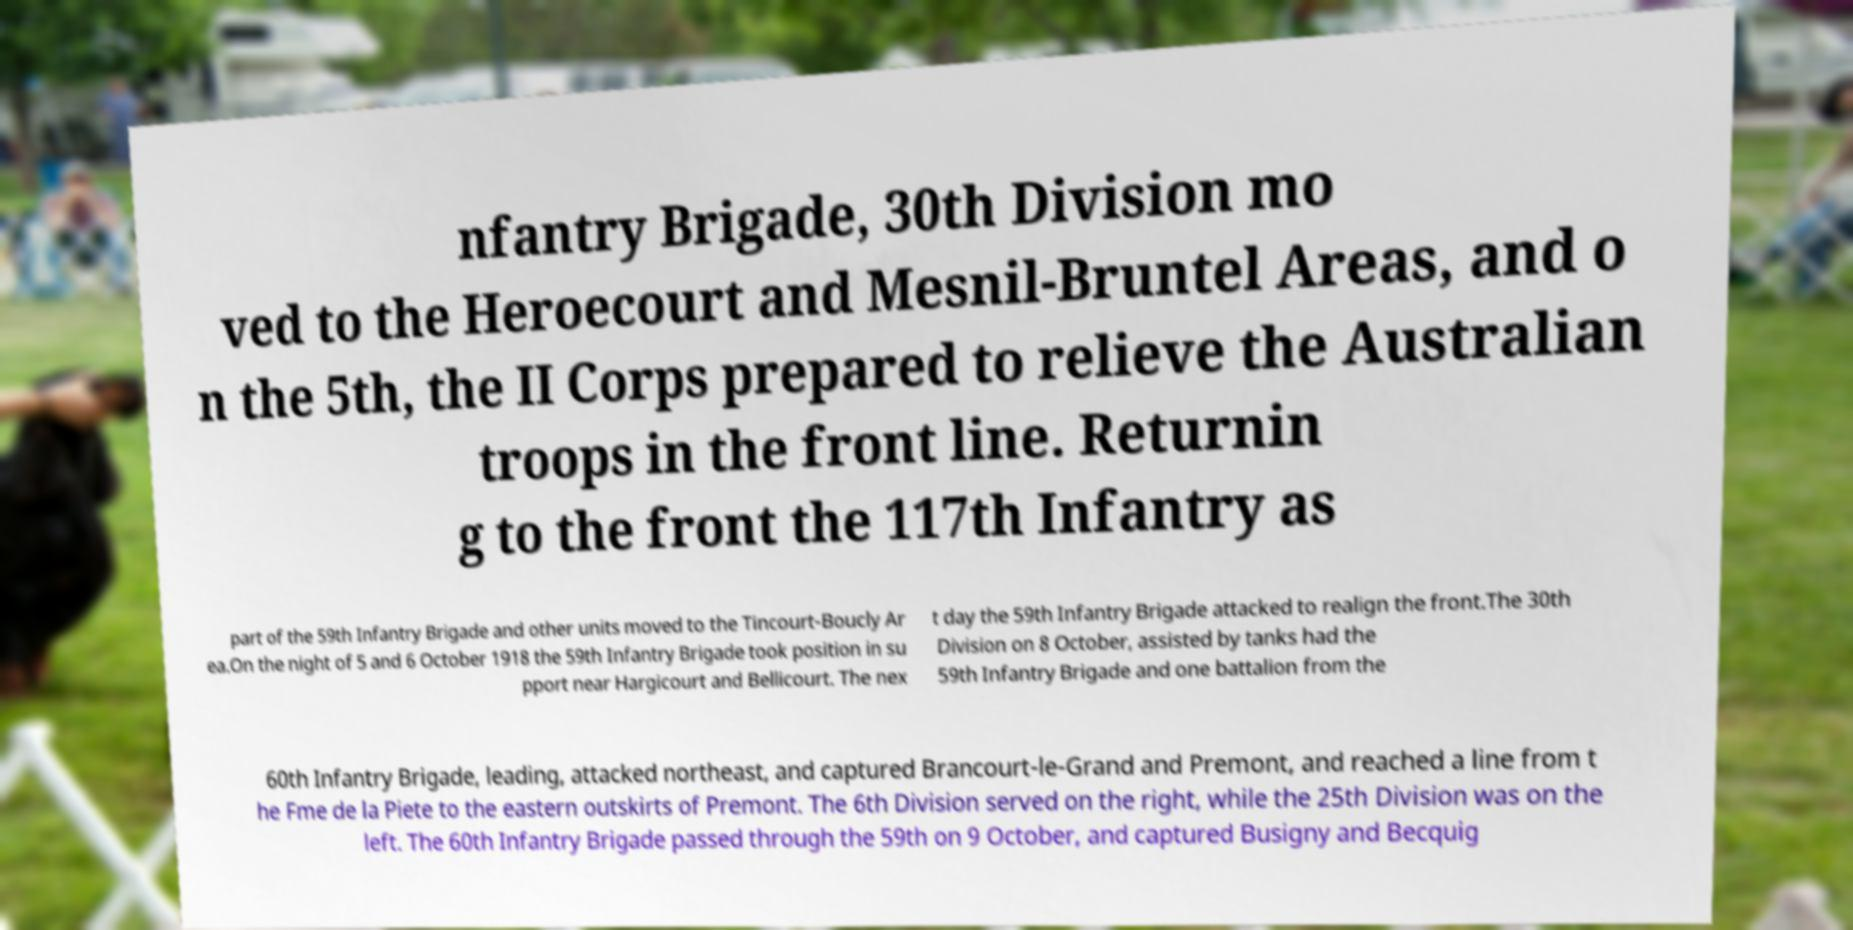Could you assist in decoding the text presented in this image and type it out clearly? nfantry Brigade, 30th Division mo ved to the Heroecourt and Mesnil-Bruntel Areas, and o n the 5th, the II Corps prepared to relieve the Australian troops in the front line. Returnin g to the front the 117th Infantry as part of the 59th Infantry Brigade and other units moved to the Tincourt-Boucly Ar ea.On the night of 5 and 6 October 1918 the 59th Infantry Brigade took position in su pport near Hargicourt and Bellicourt. The nex t day the 59th Infantry Brigade attacked to realign the front.The 30th Division on 8 October, assisted by tanks had the 59th Infantry Brigade and one battalion from the 60th Infantry Brigade, leading, attacked northeast, and captured Brancourt-le-Grand and Premont, and reached a line from t he Fme de la Piete to the eastern outskirts of Premont. The 6th Division served on the right, while the 25th Division was on the left. The 60th Infantry Brigade passed through the 59th on 9 October, and captured Busigny and Becquig 